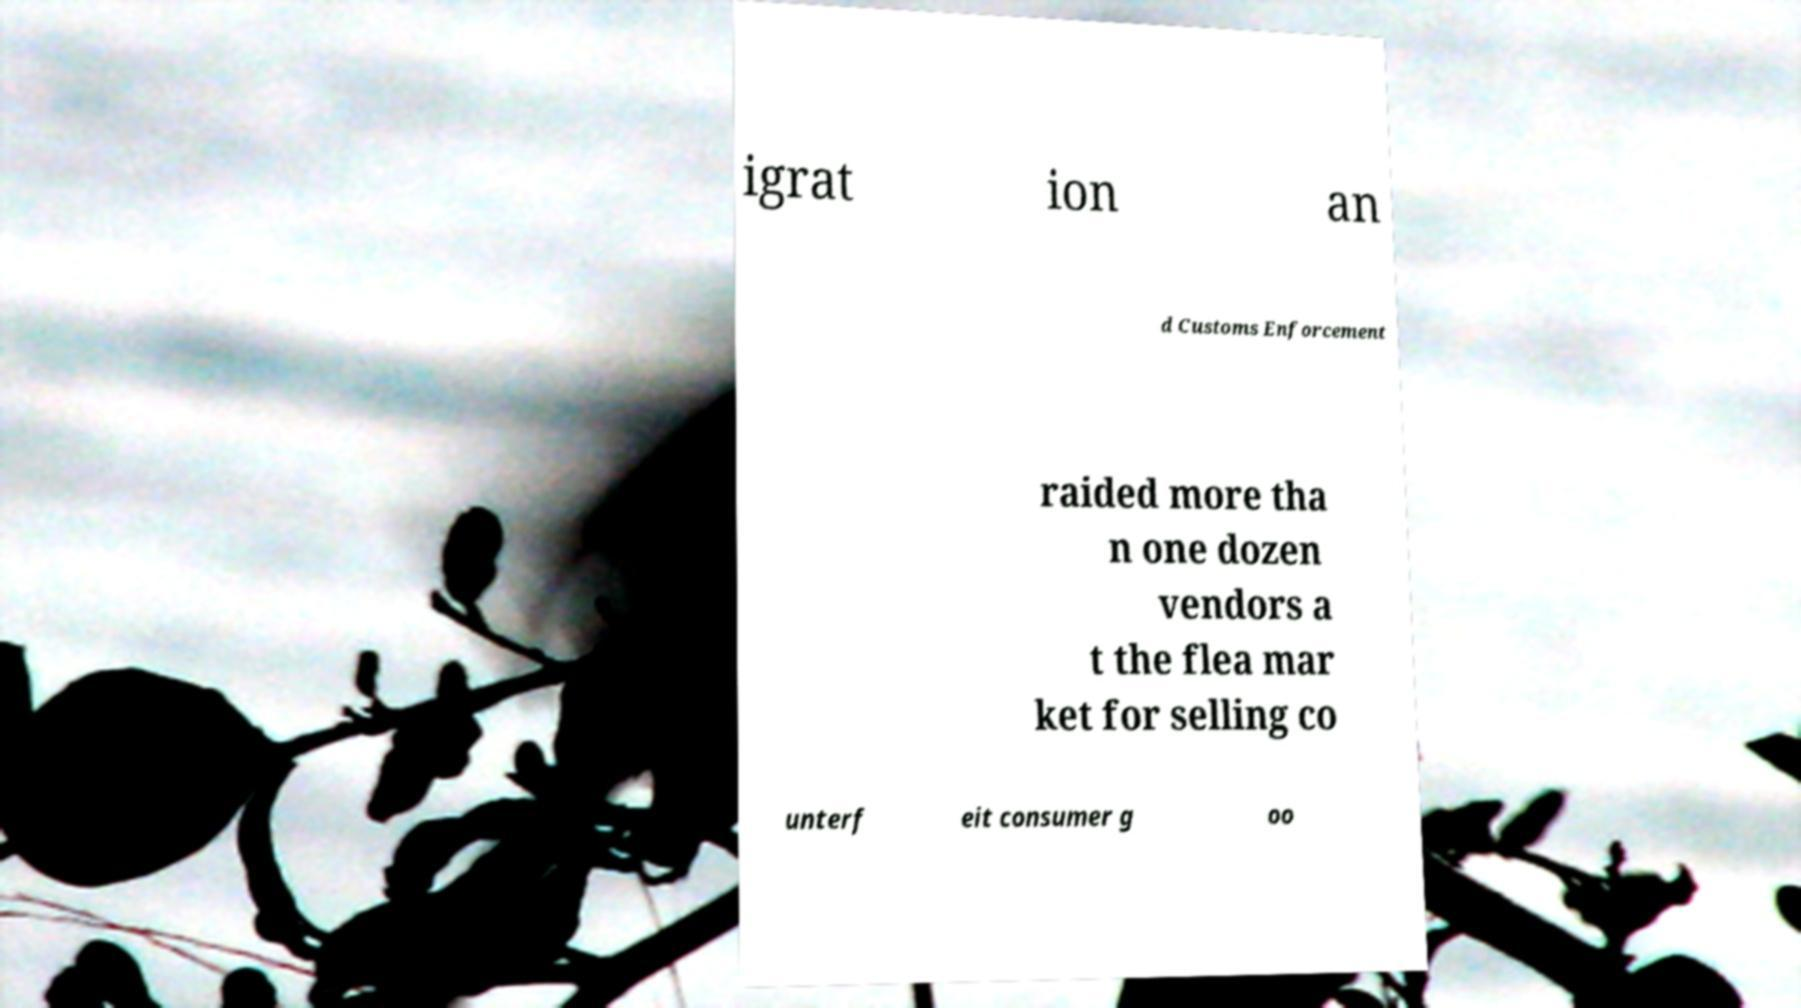I need the written content from this picture converted into text. Can you do that? igrat ion an d Customs Enforcement raided more tha n one dozen vendors a t the flea mar ket for selling co unterf eit consumer g oo 